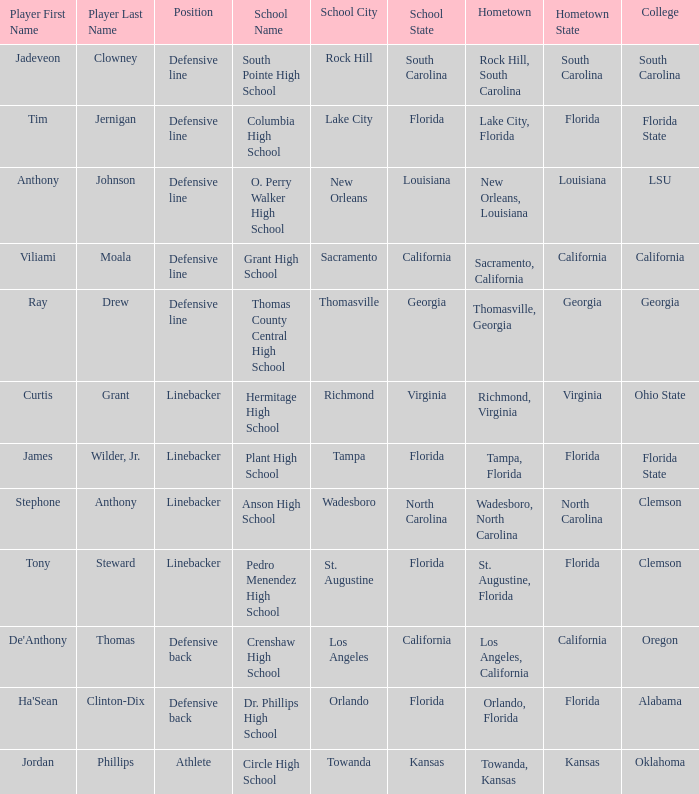I'm looking to parse the entire table for insights. Could you assist me with that? {'header': ['Player First Name', 'Player Last Name', 'Position', 'School Name', 'School City', 'School State', 'Hometown', 'Hometown State', 'College'], 'rows': [['Jadeveon', 'Clowney', 'Defensive line', 'South Pointe High School', 'Rock Hill', 'South Carolina', 'Rock Hill, South Carolina', 'South Carolina', 'South Carolina'], ['Tim', 'Jernigan', 'Defensive line', 'Columbia High School', 'Lake City', 'Florida', 'Lake City, Florida', 'Florida', 'Florida State'], ['Anthony', 'Johnson', 'Defensive line', 'O. Perry Walker High School', 'New Orleans', 'Louisiana', 'New Orleans, Louisiana', 'Louisiana', 'LSU'], ['Viliami', 'Moala', 'Defensive line', 'Grant High School', 'Sacramento', 'California', 'Sacramento, California', 'California', 'California'], ['Ray', 'Drew', 'Defensive line', 'Thomas County Central High School', 'Thomasville', 'Georgia', 'Thomasville, Georgia', 'Georgia', 'Georgia'], ['Curtis', 'Grant', 'Linebacker', 'Hermitage High School', 'Richmond', 'Virginia', 'Richmond, Virginia', 'Virginia', 'Ohio State'], ['James', 'Wilder, Jr.', 'Linebacker', 'Plant High School', 'Tampa', 'Florida', 'Tampa, Florida', 'Florida', 'Florida State'], ['Stephone', 'Anthony', 'Linebacker', 'Anson High School', 'Wadesboro', 'North Carolina', 'Wadesboro, North Carolina', 'North Carolina', 'Clemson'], ['Tony', 'Steward', 'Linebacker', 'Pedro Menendez High School', 'St. Augustine', 'Florida', 'St. Augustine, Florida', 'Florida', 'Clemson'], ["De'Anthony", 'Thomas', 'Defensive back', 'Crenshaw High School', 'Los Angeles', 'California', 'Los Angeles, California', 'California', 'Oregon'], ["Ha'Sean", 'Clinton-Dix', 'Defensive back', 'Dr. Phillips High School', 'Orlando', 'Florida', 'Orlando, Florida', 'Florida', 'Alabama'], ['Jordan', 'Phillips', 'Athlete', 'Circle High School', 'Towanda', 'Kansas', 'Towanda, Kansas', 'Kansas', 'Oklahoma']]} Which hometown has a player of Ray Drew? Thomasville, Georgia. 